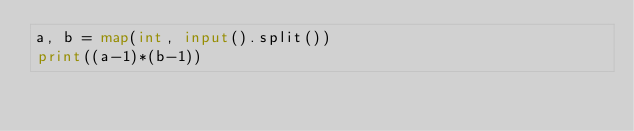<code> <loc_0><loc_0><loc_500><loc_500><_Python_>a, b = map(int, input().split())
print((a-1)*(b-1))</code> 